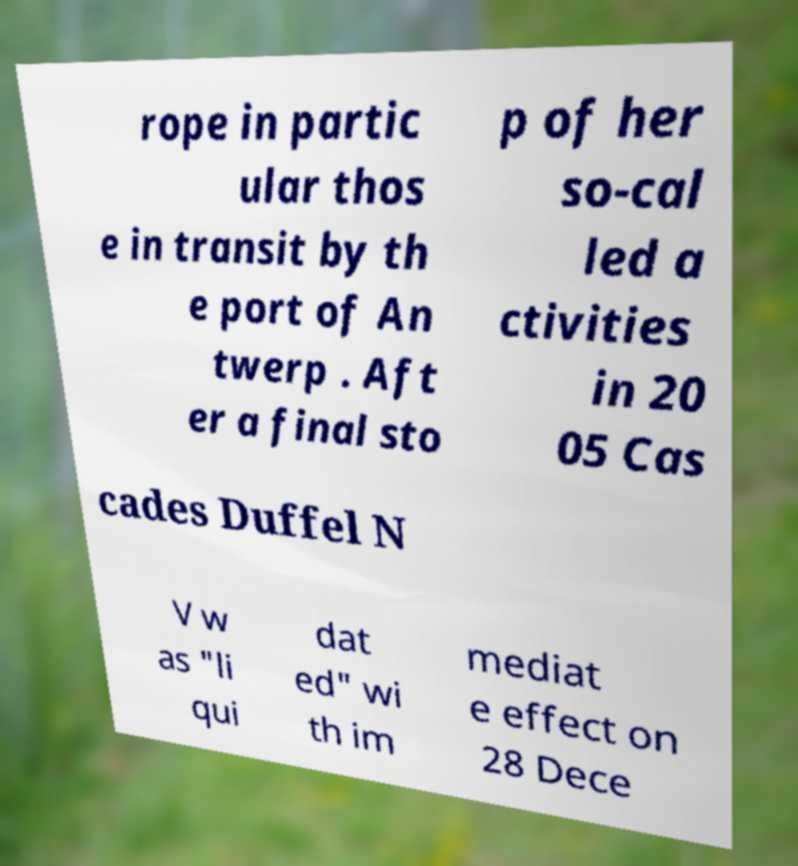What messages or text are displayed in this image? I need them in a readable, typed format. rope in partic ular thos e in transit by th e port of An twerp . Aft er a final sto p of her so-cal led a ctivities in 20 05 Cas cades Duffel N V w as "li qui dat ed" wi th im mediat e effect on 28 Dece 